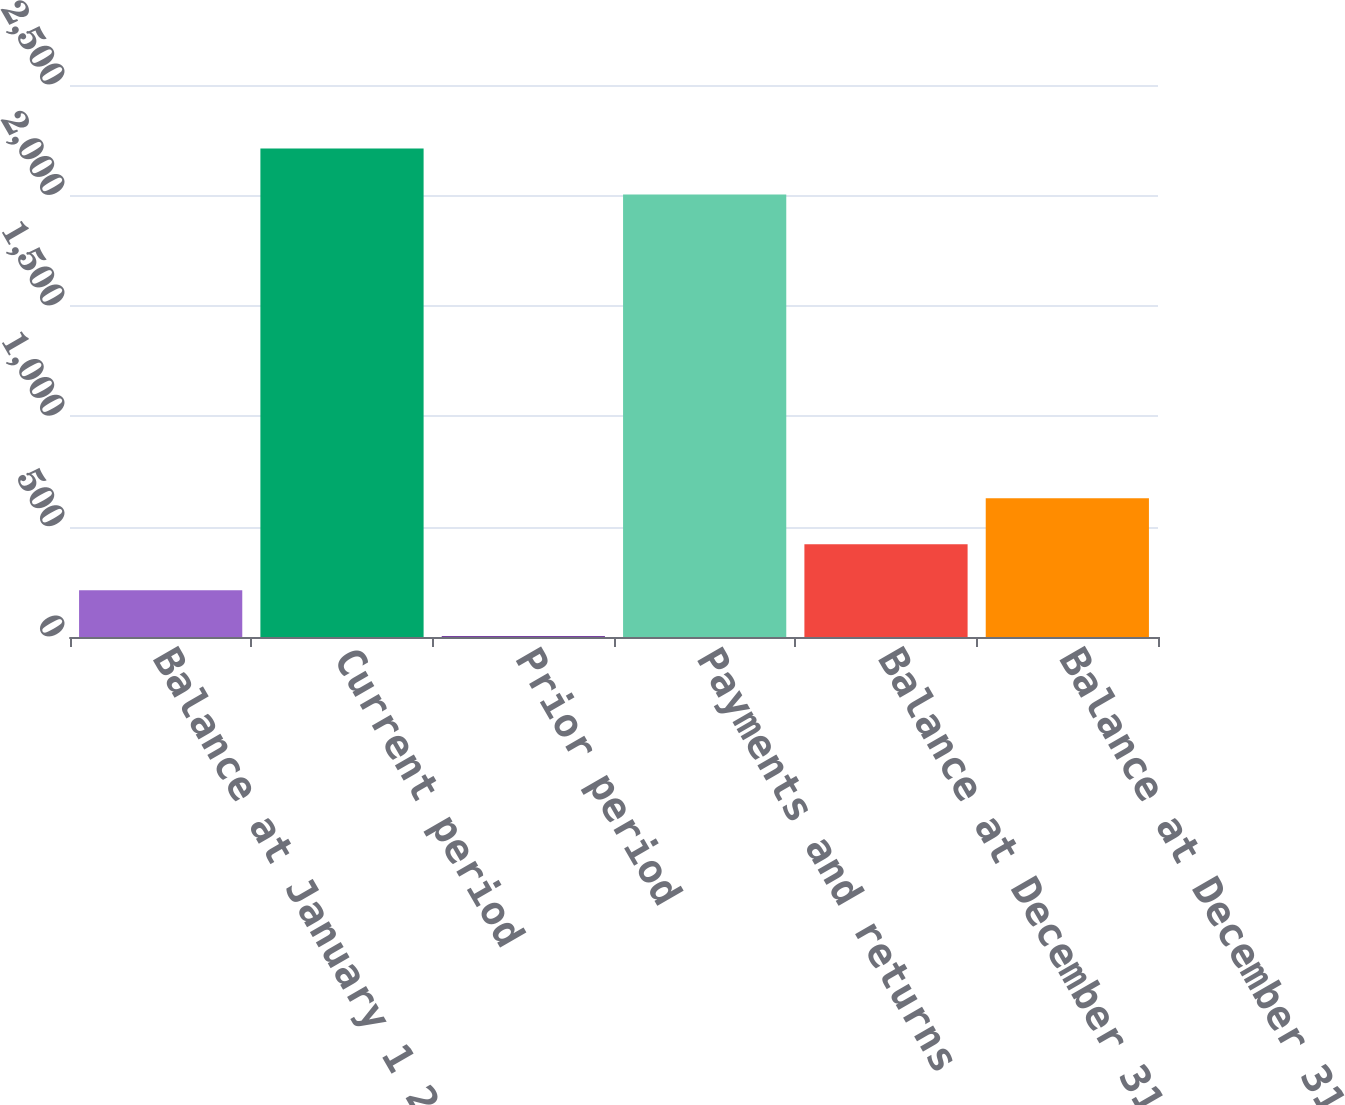Convert chart. <chart><loc_0><loc_0><loc_500><loc_500><bar_chart><fcel>Balance at January 1 2017<fcel>Current period<fcel>Prior period<fcel>Payments and returns<fcel>Balance at December 31 2017<fcel>Balance at December 31 2018<nl><fcel>211.4<fcel>2212.4<fcel>3<fcel>2004<fcel>419.8<fcel>628.2<nl></chart> 